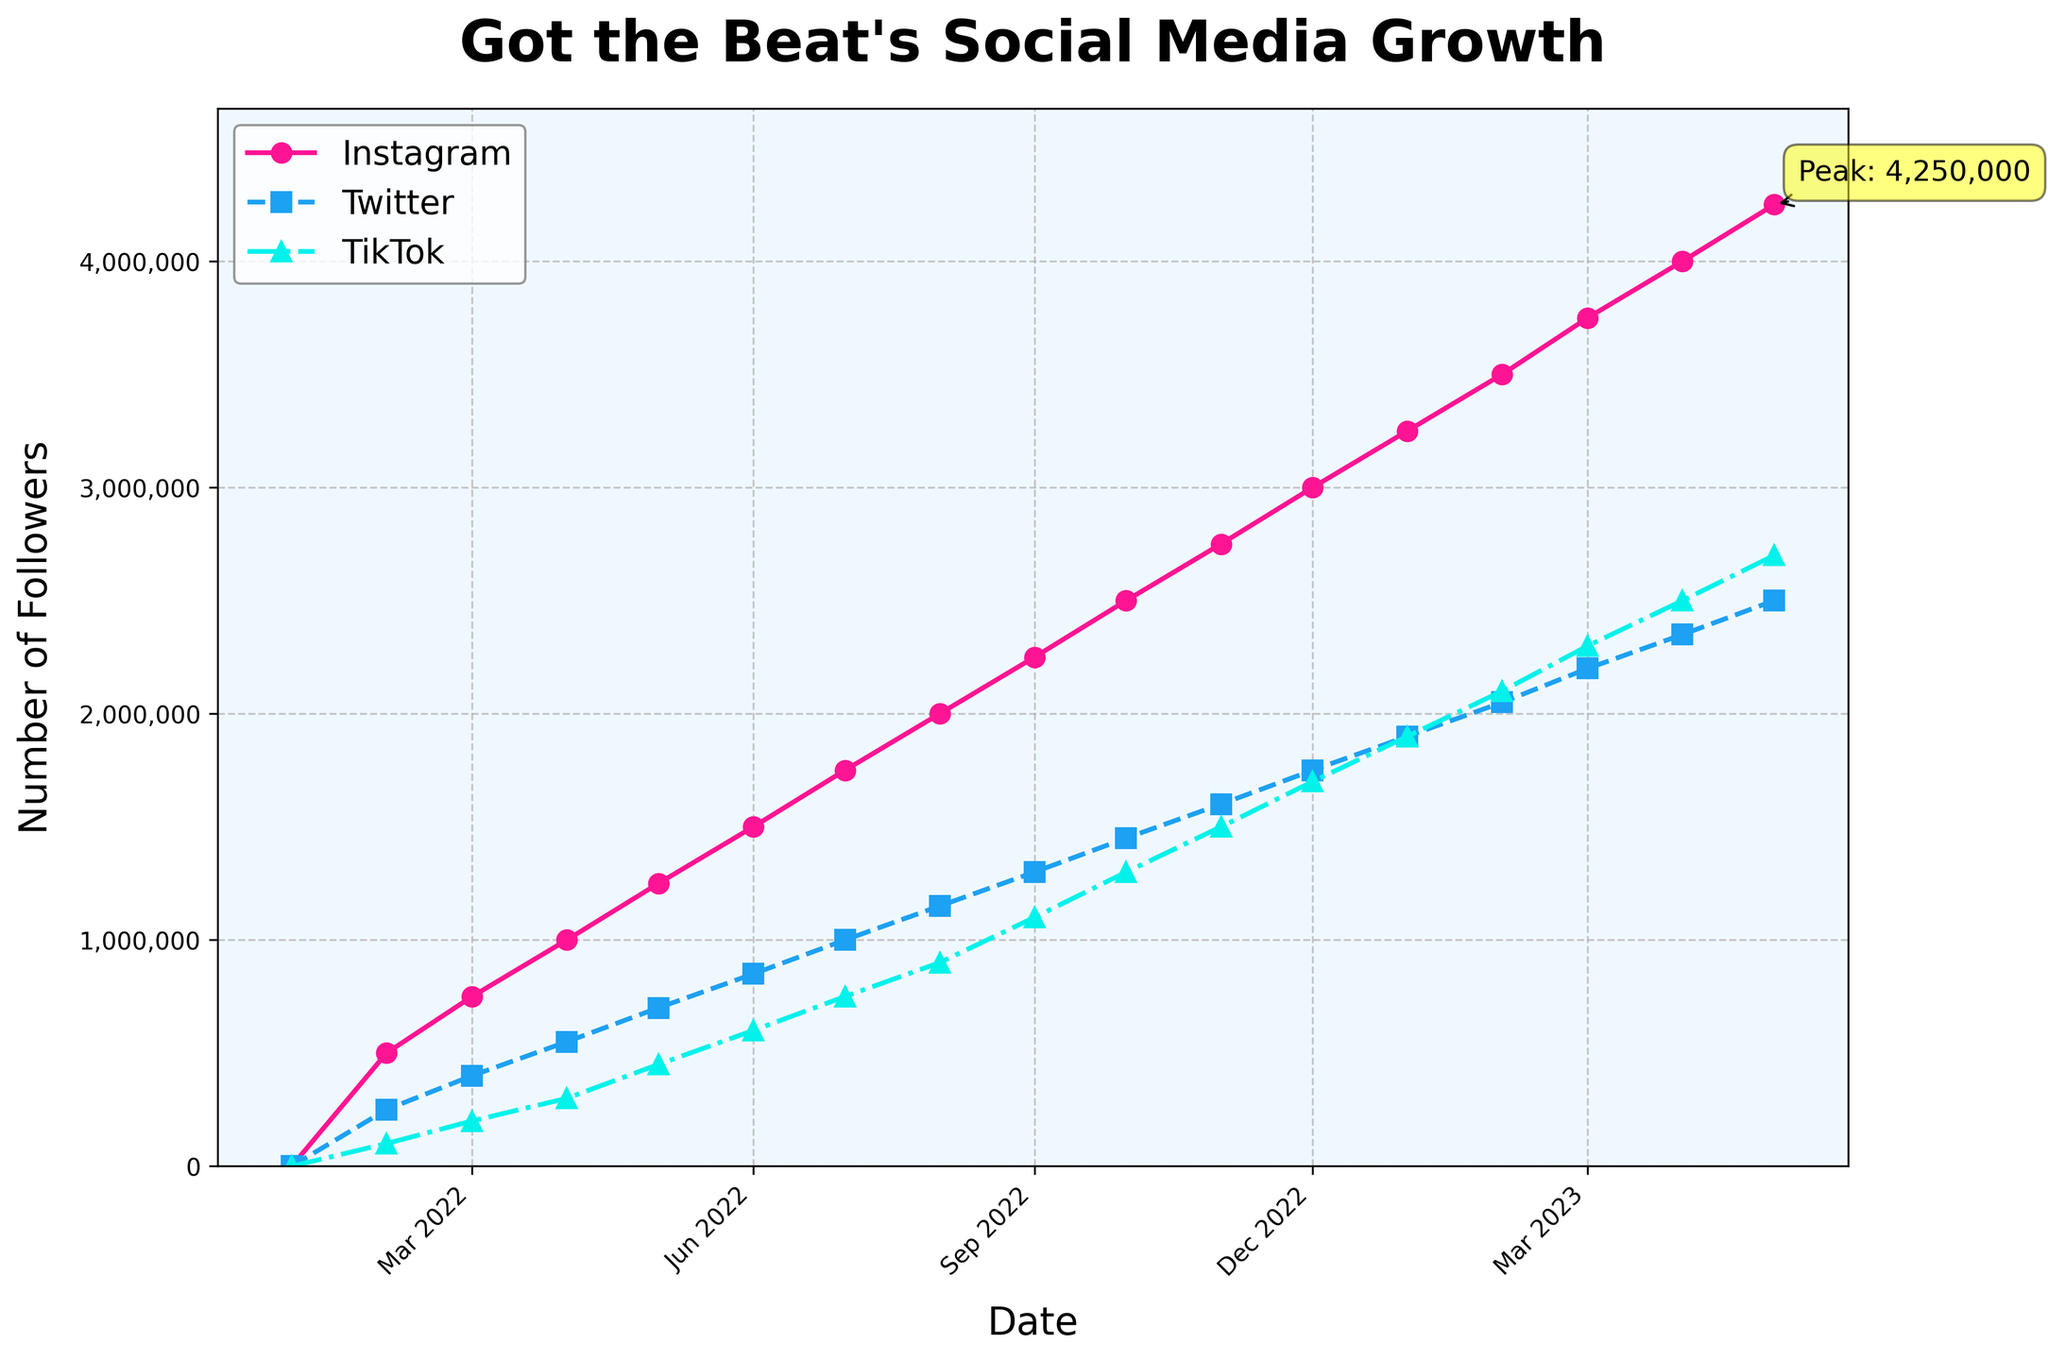what social media platform had the highest number of followers by May 2023? Look at the data points for May 2023: Instagram (4,250,000), Twitter (2,500,000), and TikTok (2,700,000). Instagram has the highest number of followers.
Answer: Instagram Which platform showed the steepest growth between January 2022 and May 2023? Evaluate the difference in followers between January 2022 and May 2023 for each platform. Instagram grew from 0 to 4,250,000 (4,250,000), Twitter grew from 0 to 2,500,000 (2,500,000), and TikTok grew from 0 to 2,700,000 (2,700,000). Instagram has the highest growth in followers.
Answer: Instagram On which date did Instagram hit the 2 million followers mark? Follow the trend of the Instagram data points over time. Instagram reached 2,000,000 followers in August 2022.
Answer: August 2022 What is the total number of followers for all platforms in April 2023? Sum the followers for each platform in April 2023: Instagram (4,000,000), Twitter (2,350,000), and TikTok (2,500,000). The total is 4,000,000 + 2,350,000 + 2,500,000 = 8,850,000.
Answer: 8,850,000 Which platform has the smallest follower count increase from February 2023 to March 2023? Subtract the February 2023 values from the March 2023 values for each platform: Instagram (3,750,000 - 3,500,000 = 250,000), Twitter (2,200,000 - 2,050,000 = 150,000), and TikTok (2,300,000 - 2,100,000 = 200,000). Twitter has the smallest increase.
Answer: Twitter What visual element indicates the peak number of followers in the chart? Look for annotations in the chart that highlight or point to significant values. The peak number of followers is indicated by an annotation (text label) and an arrow pointing to the last data point for Instagram.
Answer: Annotation and arrow Between December 2022 and January 2023, which platform had the highest rate of growth? Calculate the difference in followers between December 2022 and January 2023 for each platform: Instagram (3,250,000 - 3,000,000 = 250,000), Twitter (1,900,000 - 1,750,000 = 150,000), and TikTok (1,900,000 - 1,700,000 = 200,000). Instagram had the highest growth rate.
Answer: Instagram Among all platforms, which had the least number of followers in February 2022? Check the values for February 2022 for each platform: Instagram (500,000), Twitter (250,000), and TikTok (100,000). TikTok had the least followers.
Answer: TikTok What was the average number of Instagram followers from January 2022 to May 2023? Sum the Instagram followers from January 2022 to May 2023 and divide by the number of data points: (0 + 500,000 + 750,000 + 1,000,000 + 1,250,000 + 1,500,000 + 1,750,000 + 2,000,000 + 2,250,000 + 2,500,000 + 2,750,000 + 3,000,000 + 3,250,000 + 3,500,000 + 3,750,000 + 4,000,000 + 4,250,000) / 17. The total is 34,250,000, so the average is 34,250,000 / 17 = 2,014,706.
Answer: 2,014,706 